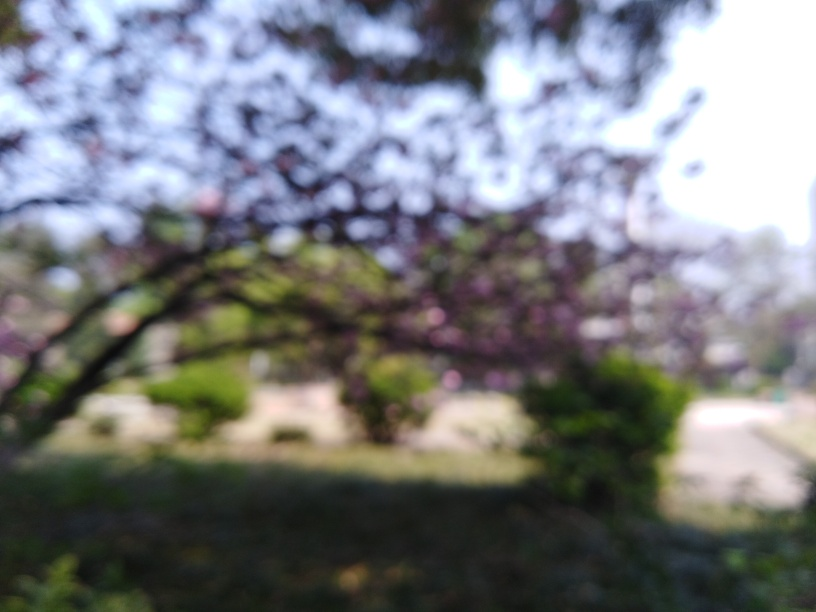Are there any distinctive objects or features that can be discerned through the blurriness? Despite the blurriness, one can observe the general shapes of trees and possibly blossoms or leaves, indicating a garden or park-like setting. The blur masks the specifics, which gives the scene a tranquil, dreamlike quality. 